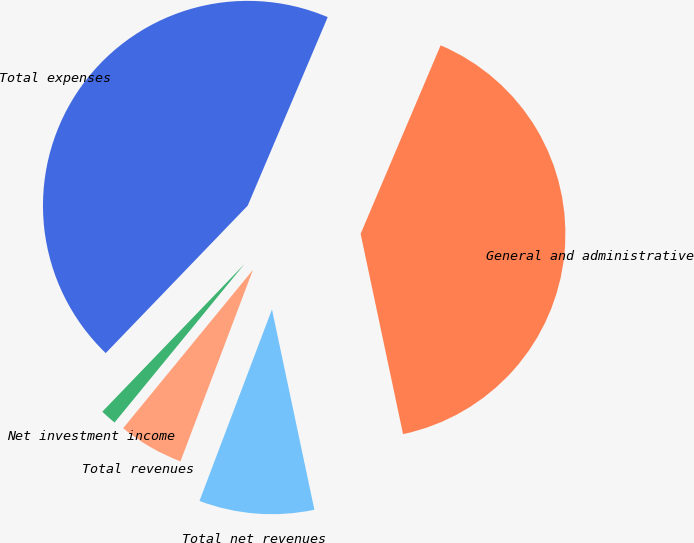<chart> <loc_0><loc_0><loc_500><loc_500><pie_chart><fcel>Net investment income<fcel>Total revenues<fcel>Total net revenues<fcel>General and administrative<fcel>Total expenses<nl><fcel>1.27%<fcel>5.17%<fcel>9.08%<fcel>40.29%<fcel>44.19%<nl></chart> 